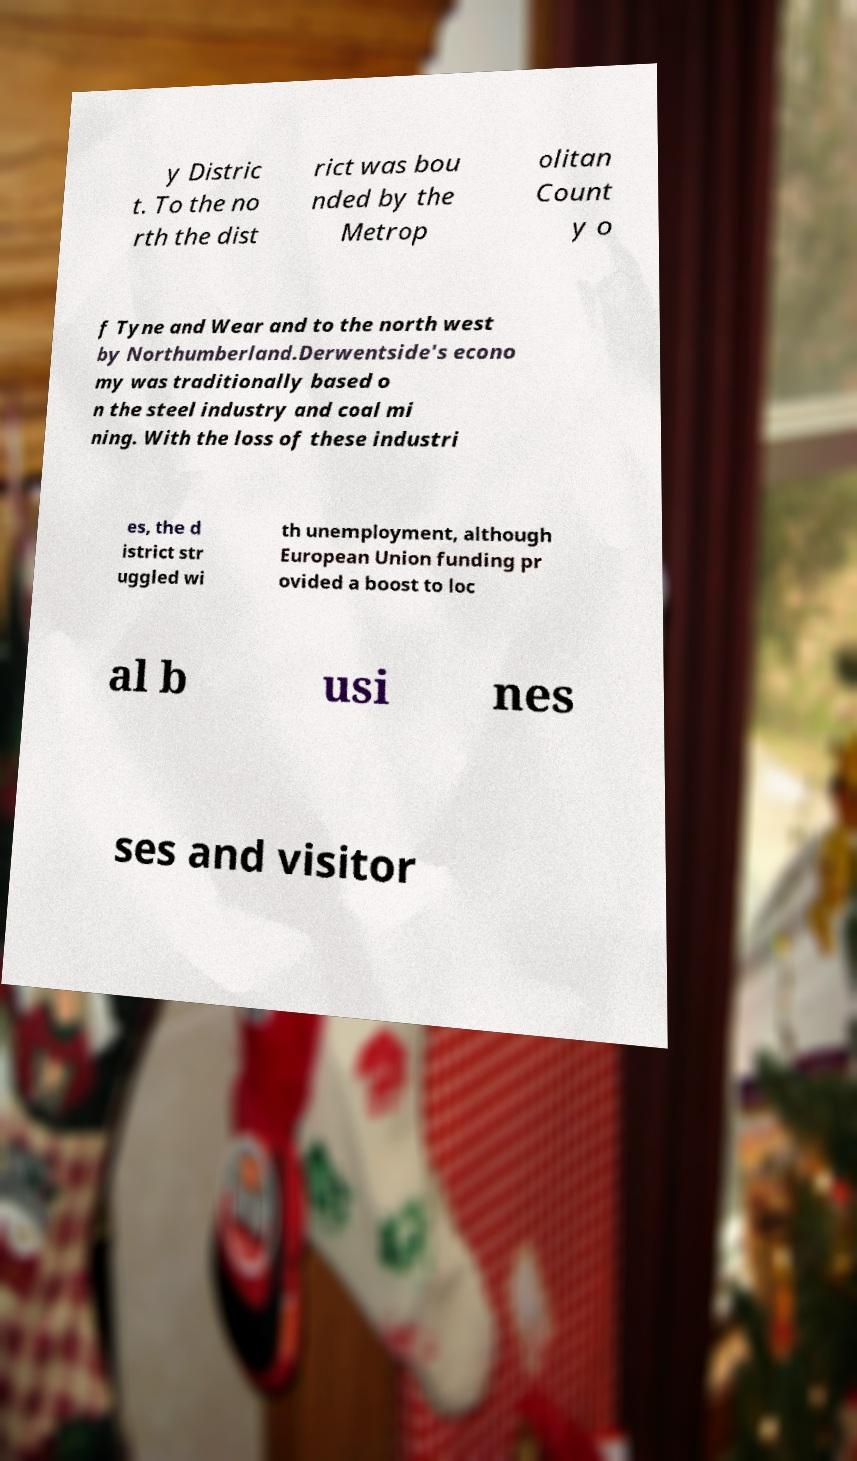There's text embedded in this image that I need extracted. Can you transcribe it verbatim? y Distric t. To the no rth the dist rict was bou nded by the Metrop olitan Count y o f Tyne and Wear and to the north west by Northumberland.Derwentside's econo my was traditionally based o n the steel industry and coal mi ning. With the loss of these industri es, the d istrict str uggled wi th unemployment, although European Union funding pr ovided a boost to loc al b usi nes ses and visitor 